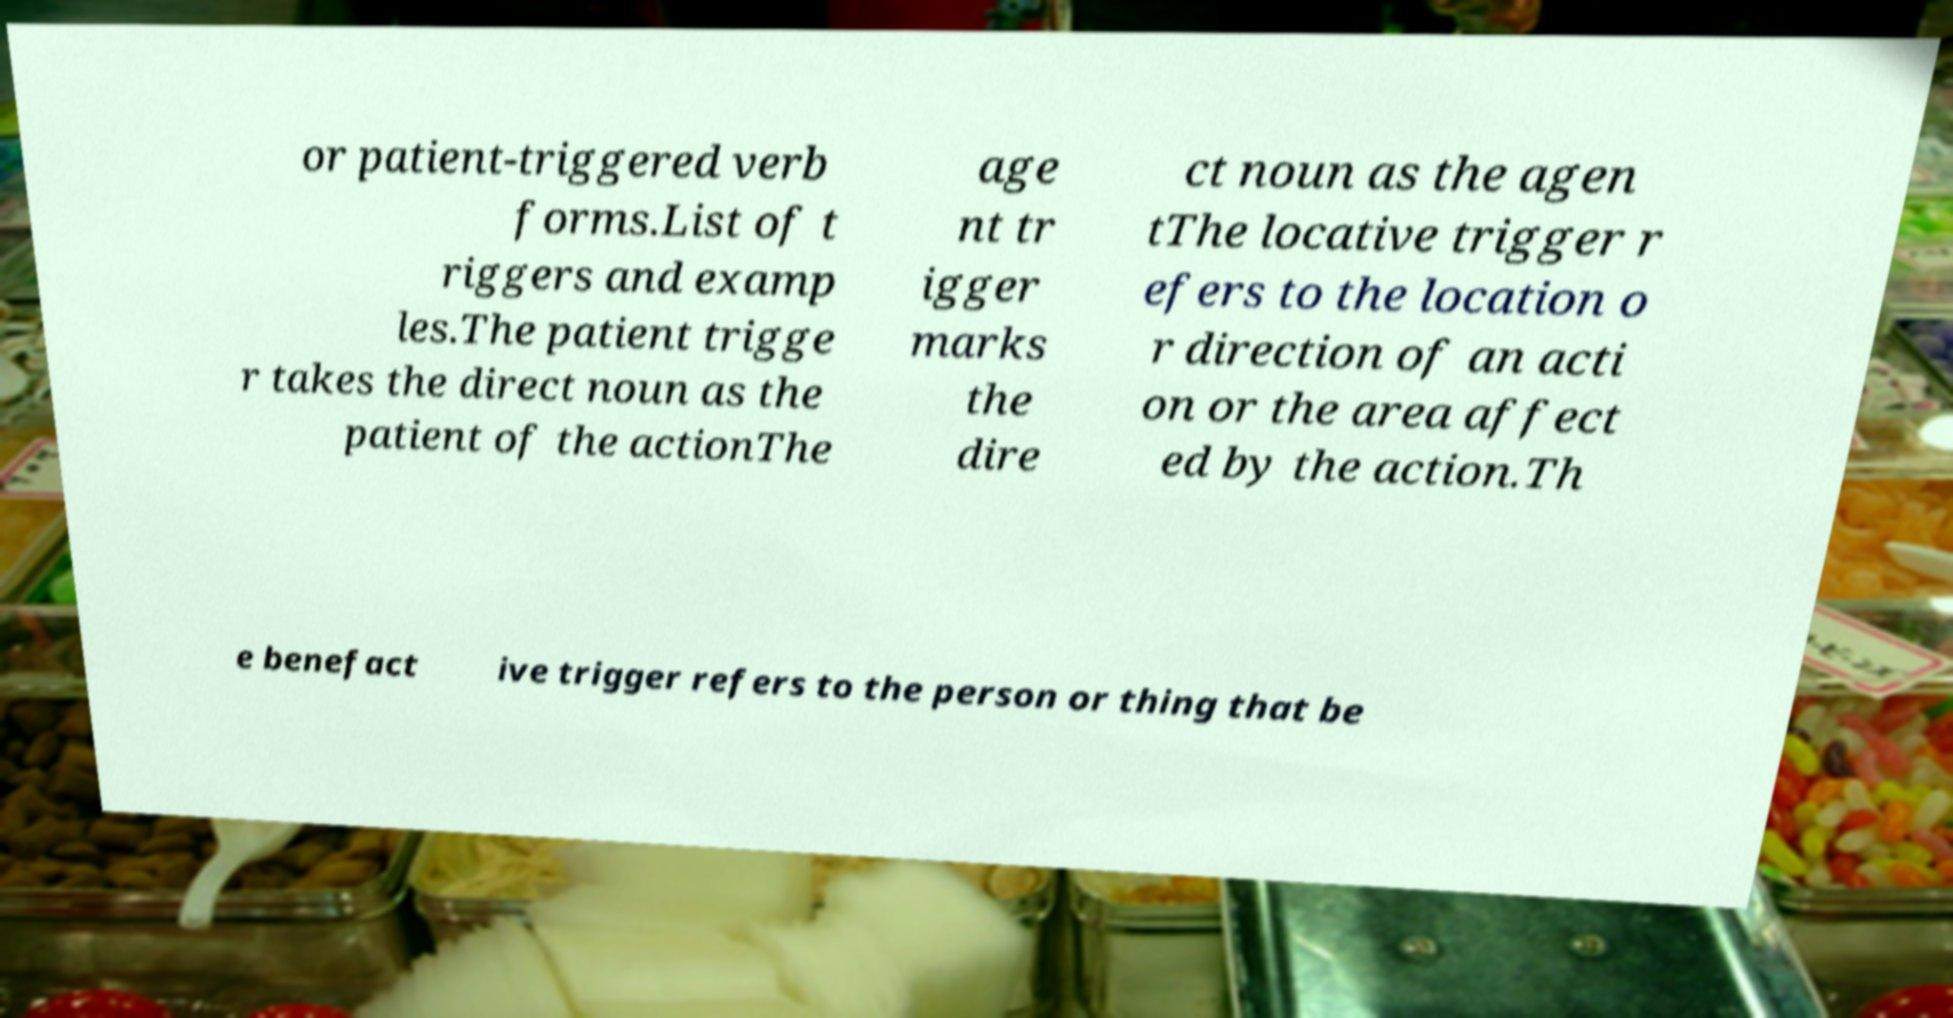Could you extract and type out the text from this image? or patient-triggered verb forms.List of t riggers and examp les.The patient trigge r takes the direct noun as the patient of the actionThe age nt tr igger marks the dire ct noun as the agen tThe locative trigger r efers to the location o r direction of an acti on or the area affect ed by the action.Th e benefact ive trigger refers to the person or thing that be 